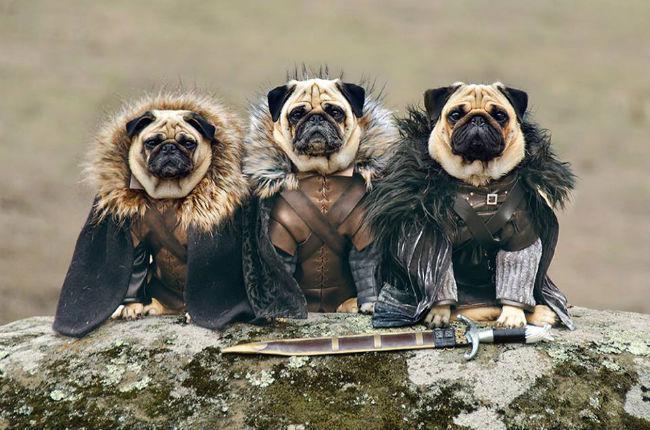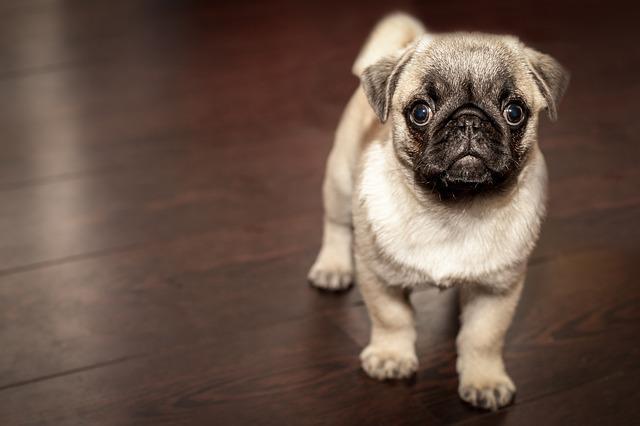The first image is the image on the left, the second image is the image on the right. Analyze the images presented: Is the assertion "An image contains at least three pug dogs dressed in garments other than dog collars." valid? Answer yes or no. Yes. The first image is the image on the left, the second image is the image on the right. Considering the images on both sides, is "In one of the images, at least one of the dogs is entirely black." valid? Answer yes or no. No. 